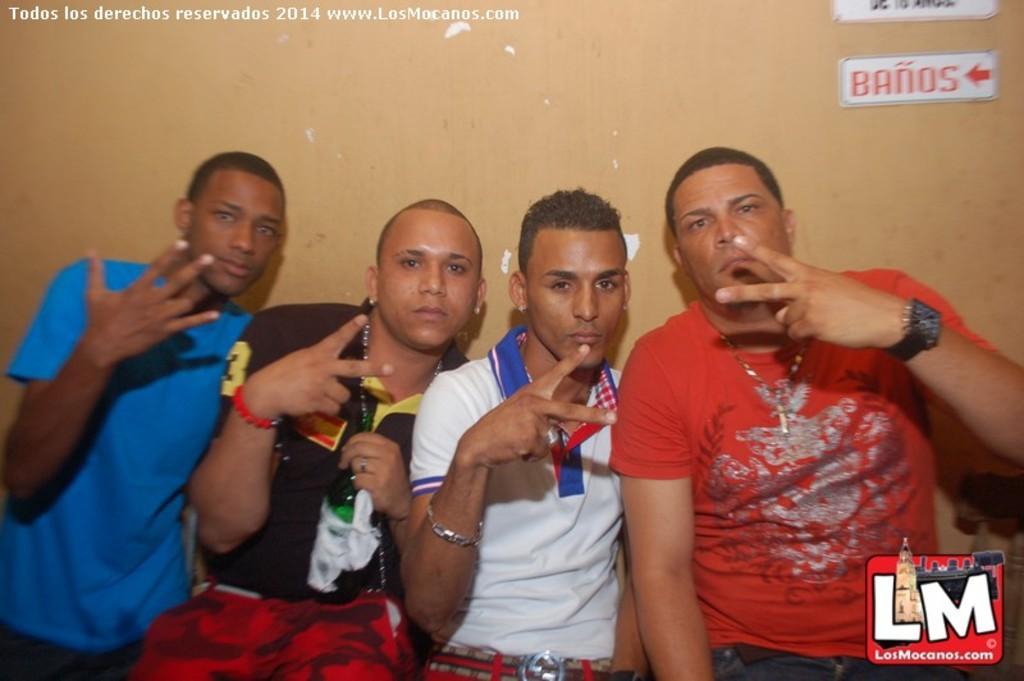How would you summarize this image in a sentence or two? In this image there are few persons showing some hand gestures. A person wearing a red shirt is having watch to his hand. Behind them there is wall having few poster attached to it. 